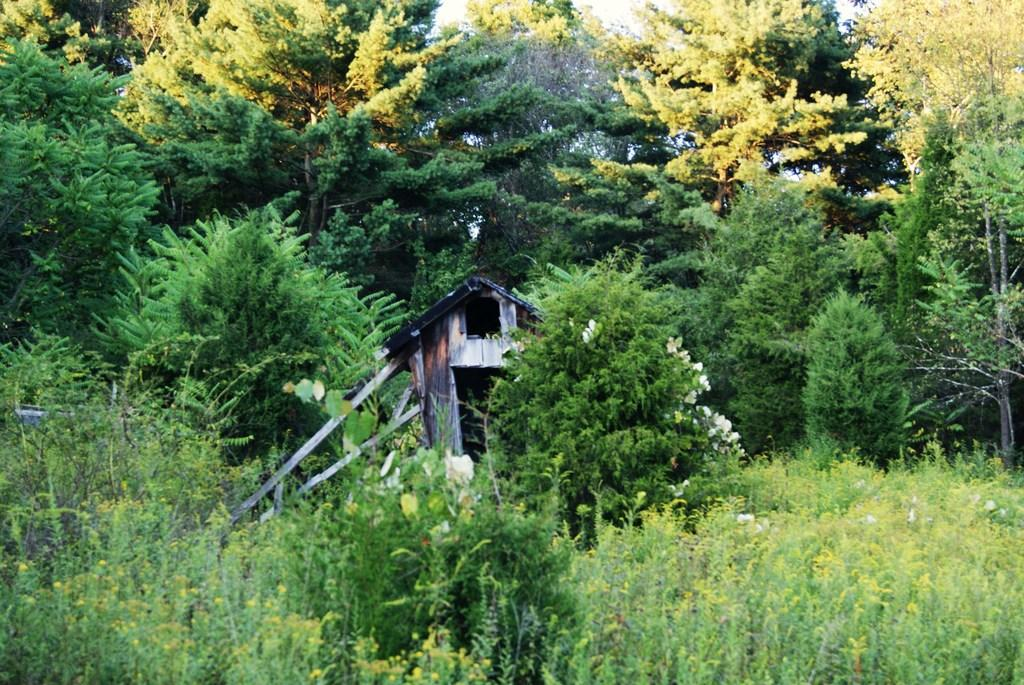Where was the image taken? The image is taken outdoors. What is the main structure visible in the image? There is a wooden cabin in the middle of the image. What type of vegetation can be seen in the image? There are many trees and plants in the image. Can you hear the bells ringing in the image? There are no bells present in the image, so it is not possible to hear them ringing. 